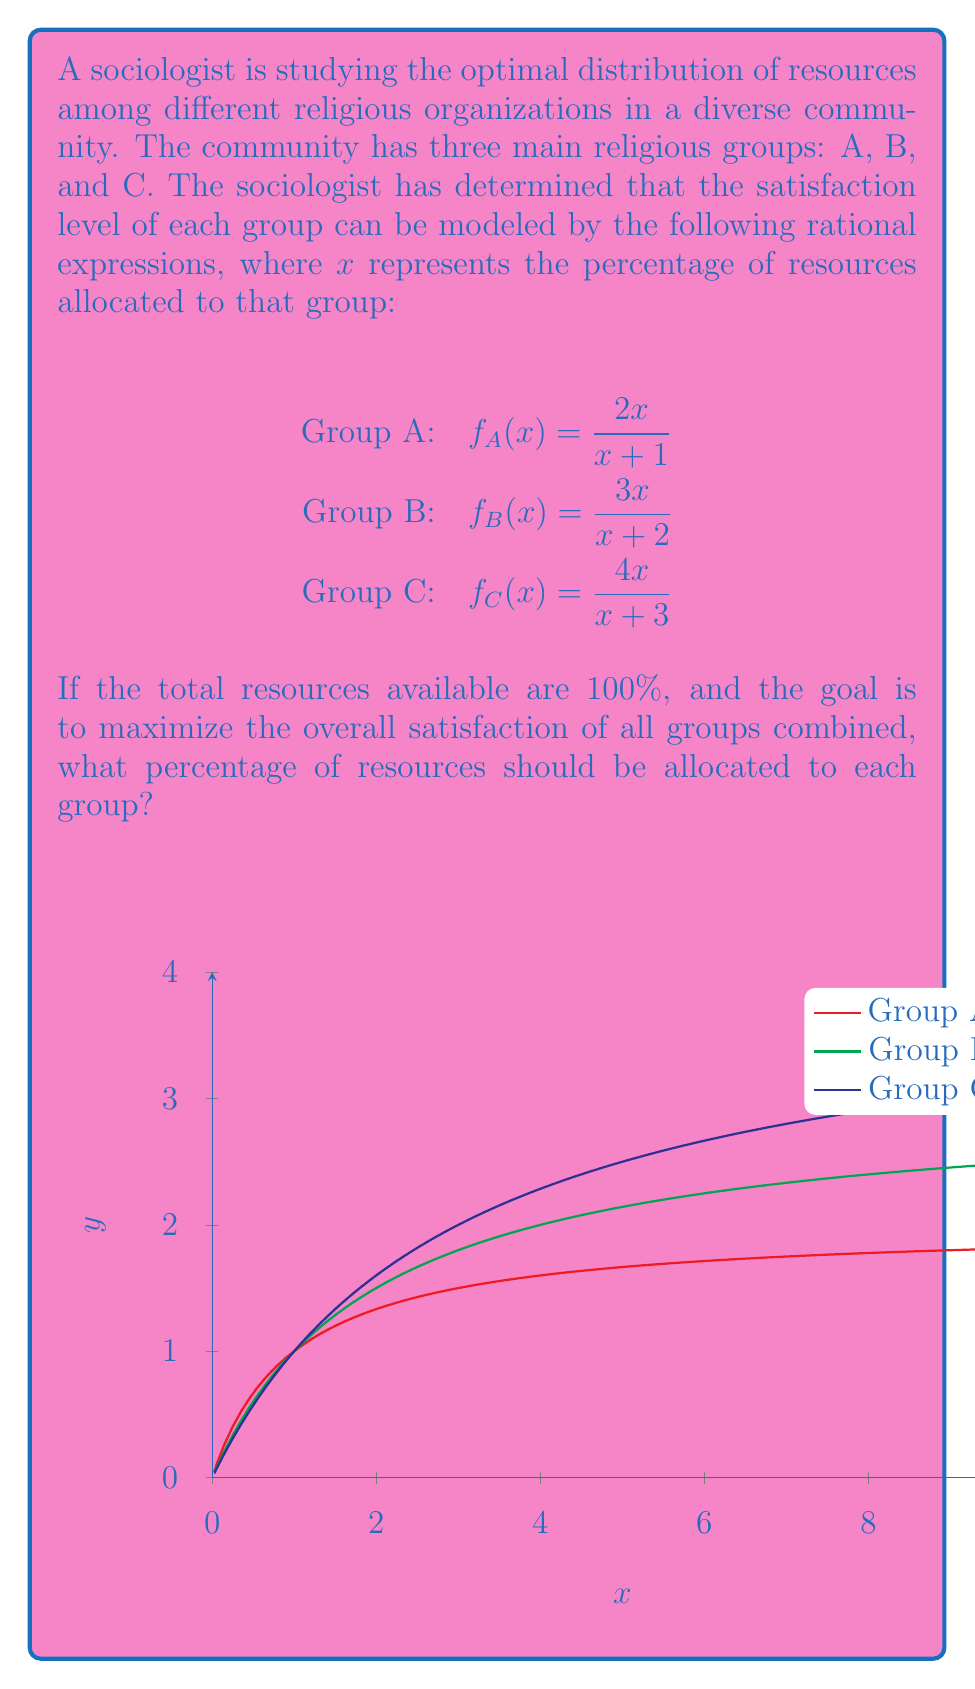Could you help me with this problem? To solve this problem, we need to follow these steps:

1) First, we need to create a function that represents the total satisfaction of all groups:

   $S(x,y,z) = f_A(x) + f_B(y) + f_C(z) = \frac{2x}{x+1} + \frac{3y}{y+2} + \frac{4z}{z+3}$

2) We have the constraint that $x + y + z = 100$ (total resources).

3) To maximize $S$, we need to find where its partial derivatives are equal:

   $\frac{\partial S}{\partial x} = \frac{\partial S}{\partial y} = \frac{\partial S}{\partial z}$

4) Calculating these partial derivatives:

   $\frac{\partial S}{\partial x} = \frac{2}{(x+1)^2}$
   $\frac{\partial S}{\partial y} = \frac{6}{(y+2)^2}$
   $\frac{\partial S}{\partial z} = \frac{12}{(z+3)^2}$

5) Setting these equal to each other:

   $\frac{2}{(x+1)^2} = \frac{6}{(y+2)^2} = \frac{12}{(z+3)^2}$

6) This implies:

   $x+1 = \frac{1}{\sqrt{2}}(y+2) = \frac{1}{2}(z+3)$

7) Solving these equations along with the constraint $x + y + z = 100$, we get:

   $x \approx 24.4$
   $y \approx 36.6$
   $z \approx 39.0$

8) Rounding to the nearest whole percentage:

   Group A: 24%
   Group B: 37%
   Group C: 39%
Answer: A: 24%, B: 37%, C: 39% 